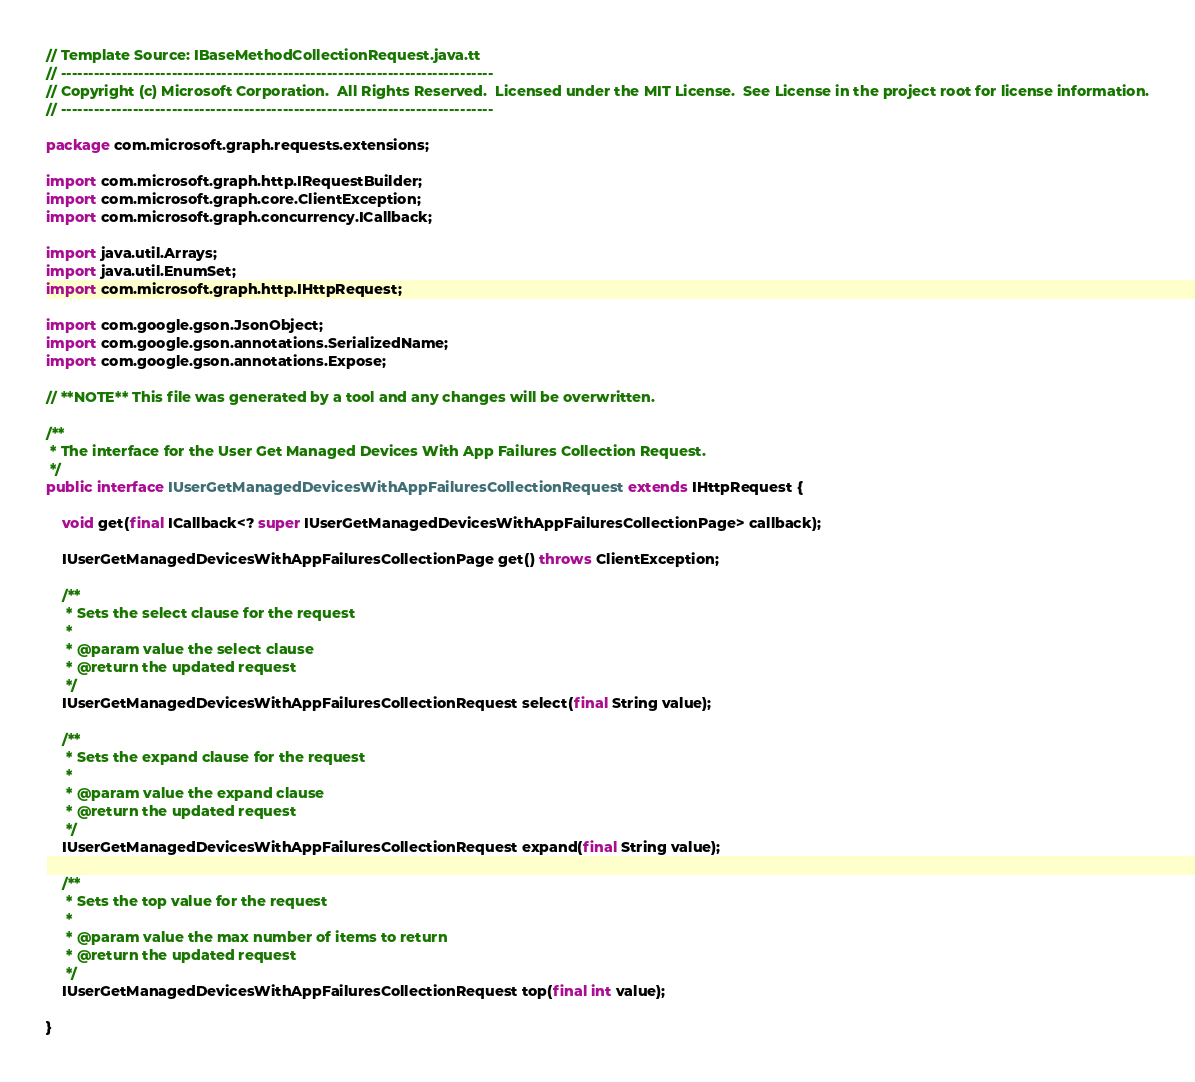<code> <loc_0><loc_0><loc_500><loc_500><_Java_>// Template Source: IBaseMethodCollectionRequest.java.tt
// ------------------------------------------------------------------------------
// Copyright (c) Microsoft Corporation.  All Rights Reserved.  Licensed under the MIT License.  See License in the project root for license information.
// ------------------------------------------------------------------------------

package com.microsoft.graph.requests.extensions;

import com.microsoft.graph.http.IRequestBuilder;
import com.microsoft.graph.core.ClientException;
import com.microsoft.graph.concurrency.ICallback;

import java.util.Arrays;
import java.util.EnumSet;
import com.microsoft.graph.http.IHttpRequest;

import com.google.gson.JsonObject;
import com.google.gson.annotations.SerializedName;
import com.google.gson.annotations.Expose;

// **NOTE** This file was generated by a tool and any changes will be overwritten.

/**
 * The interface for the User Get Managed Devices With App Failures Collection Request.
 */
public interface IUserGetManagedDevicesWithAppFailuresCollectionRequest extends IHttpRequest {

    void get(final ICallback<? super IUserGetManagedDevicesWithAppFailuresCollectionPage> callback);

    IUserGetManagedDevicesWithAppFailuresCollectionPage get() throws ClientException;

    /**
     * Sets the select clause for the request
     *
     * @param value the select clause
     * @return the updated request
     */
    IUserGetManagedDevicesWithAppFailuresCollectionRequest select(final String value);

    /**
     * Sets the expand clause for the request
     *
     * @param value the expand clause
     * @return the updated request
     */
    IUserGetManagedDevicesWithAppFailuresCollectionRequest expand(final String value);

    /**
     * Sets the top value for the request
     *
     * @param value the max number of items to return
     * @return the updated request
     */
    IUserGetManagedDevicesWithAppFailuresCollectionRequest top(final int value);

}
</code> 